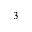<formula> <loc_0><loc_0><loc_500><loc_500>^ { 3 }</formula> 